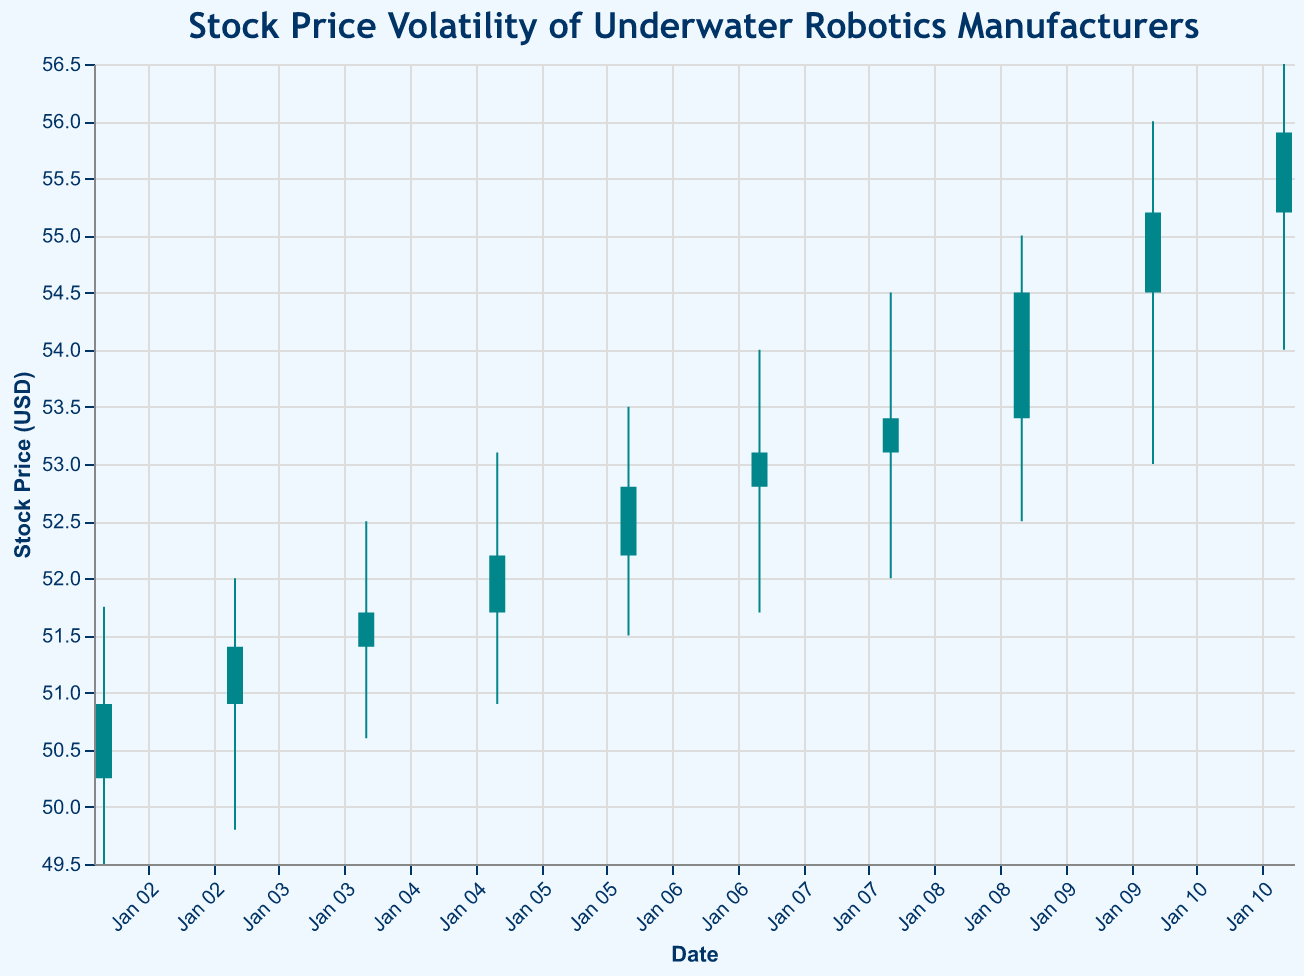What is the title of the figure? The figure's title is positioned at the top and clearly states the purpose of the plot.
Answer: Stock Price Volatility of Underwater Robotics Manufacturers What are the companies represented in the figure? The companies' names appear in the dataset's information corresponding to each date.
Answer: AbyssTech Robotics, Poseidon Industries, DeepBlue Innovations, Triton Submarines On which date did Poseidon Industries have the highest closing price? By scanning the plot, we can see Poseidon Industries' highest closing price indicated on January 11.
Answer: January 11 Which date shows the highest trading volume? The highest trading volume is represented by the highest point in the volume section of the plot, corresponding to January 11.
Answer: January 11 What was the closing price for AbyssTech Robotics on January 10? Locate January 10 on the x-axis and check the closing price for AbyssTech Robotics, indicated by the upper end of the candlestick.
Answer: 55.20 Which company had the highest stock price during the observed period? By looking for the highest point on the y-axis across all companies, we can find the highest stock price.
Answer: AbyssTech Robotics (56.00 on January 10) How did the stock price of Triton Submarines change from January 5 to January 9? Compare the closing prices on January 5 and January 9. Triton Submarines' stock price increased from 52.20 to 54.50.
Answer: Increased Which company had the smallest difference between its high and low price on any given day? Calculate the difference between high and low prices for each day and compare. AbyssTech Robotics, on January 2, had the smallest difference (51.75 - 49.50 = 2.25).
Answer: AbyssTech Robotics on January 2 On which date did DeepBlue Innovations see the most volatility in their stock price? The most volatility is indicated by the largest difference between the high and low prices for DeepBlue Innovations. On January 8, the difference was 2.50 (54.50 - 52.00).
Answer: January 8 